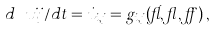<formula> <loc_0><loc_0><loc_500><loc_500>d \ u i j / d t = \dot { u } _ { i , j } = g _ { i , j } ( \vec { u } , \gamma , \alpha ) \, ,</formula> 